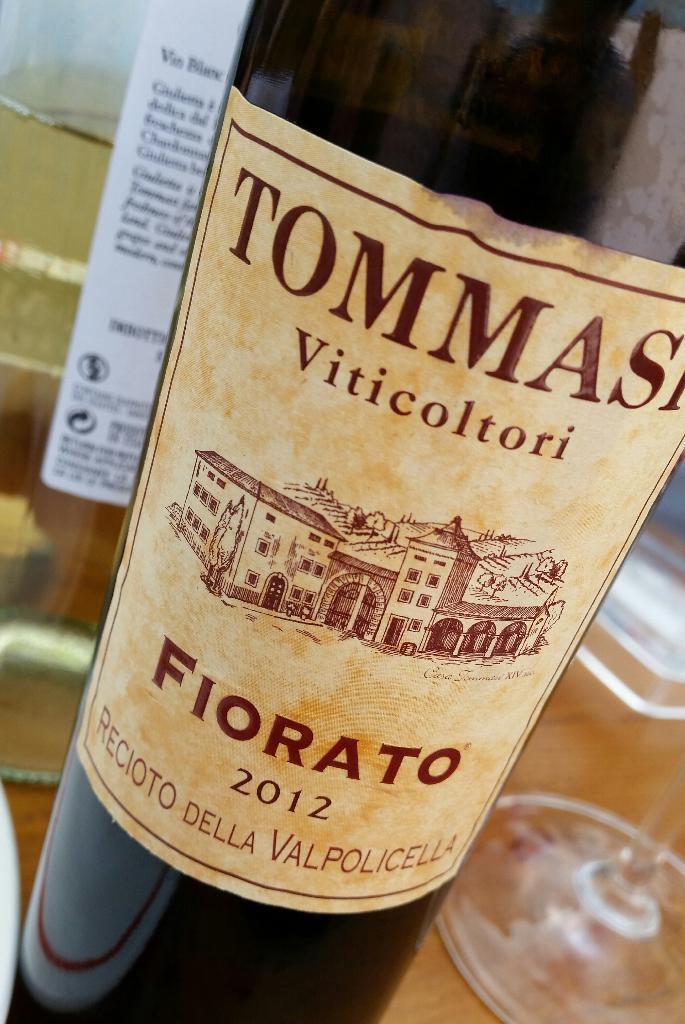<image>
Present a compact description of the photo's key features. A bottle of Fiorato sitting on a table near a glass. 